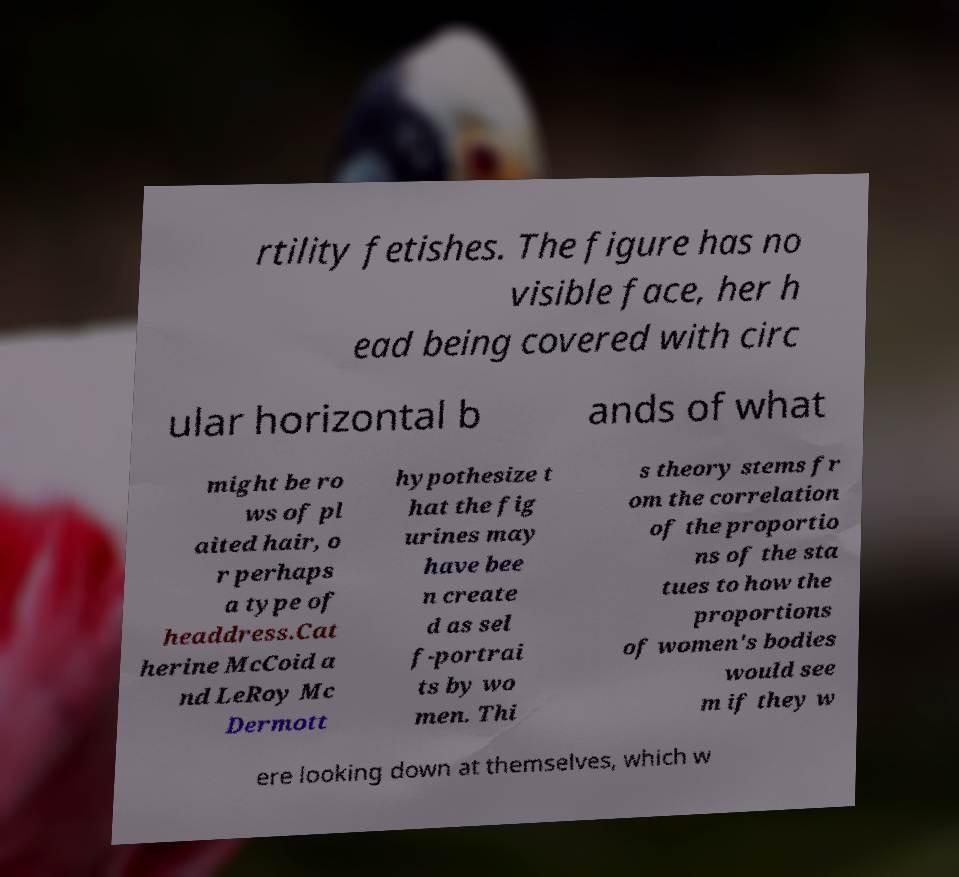Could you extract and type out the text from this image? rtility fetishes. The figure has no visible face, her h ead being covered with circ ular horizontal b ands of what might be ro ws of pl aited hair, o r perhaps a type of headdress.Cat herine McCoid a nd LeRoy Mc Dermott hypothesize t hat the fig urines may have bee n create d as sel f-portrai ts by wo men. Thi s theory stems fr om the correlation of the proportio ns of the sta tues to how the proportions of women's bodies would see m if they w ere looking down at themselves, which w 